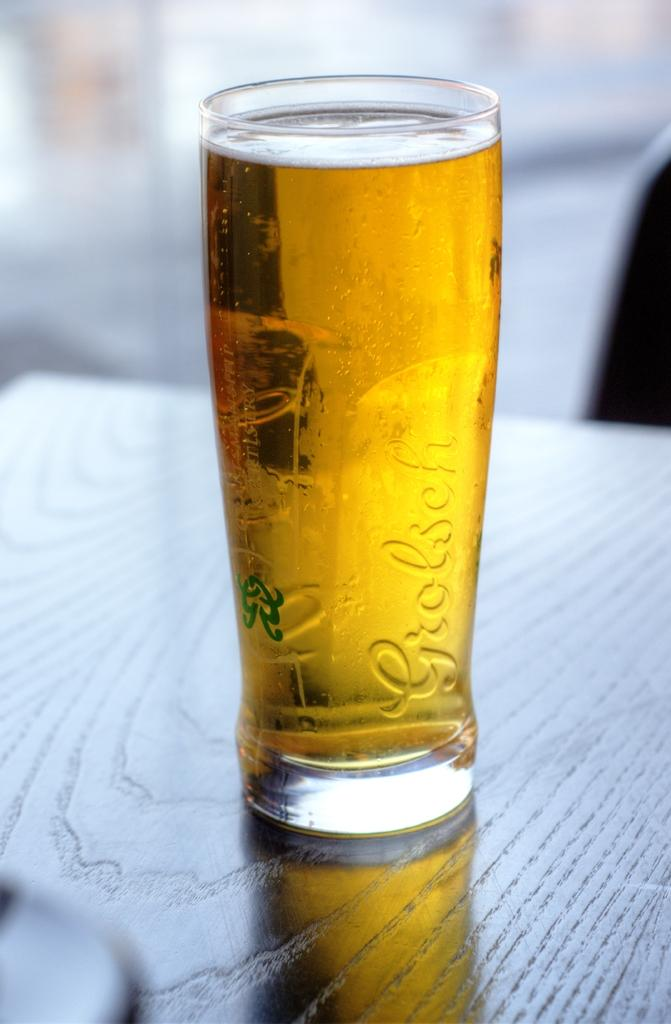<image>
Relay a brief, clear account of the picture shown. a full glass of beer with the brand grolesch on its side. 